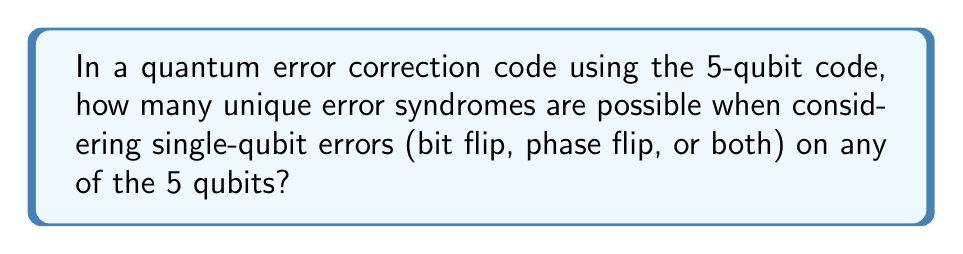Show me your answer to this math problem. To solve this problem, let's break it down step-by-step:

1) First, we need to understand what types of errors we're considering:
   - Bit flip (X error)
   - Phase flip (Z error)
   - Both bit and phase flip (Y error)
   - No error (I, identity)

2) We have 5 qubits, and each qubit can be in one of these 4 states.

3) However, the "no error" state is not considered a unique error syndrome, as it represents the correct state.

4) So, for each qubit, we have 3 possible error states (X, Y, or Z).

5) We need to consider errors on any of the 5 qubits, but only single-qubit errors.

6) This scenario can be represented mathematically as:

   $$(3 \text{ error types}) \times (5 \text{ qubits}) = 15$$

7) Additionally, we need to include the case where no error occurs on any qubit, which adds 1 more possibility.

8) Therefore, the total number of unique error syndromes is:

   $$15 + 1 = 16$$

This result aligns with the fact that the 5-qubit code can detect and correct any single-qubit error, which requires at least 16 unique syndromes (15 for errors and 1 for no error).
Answer: 16 